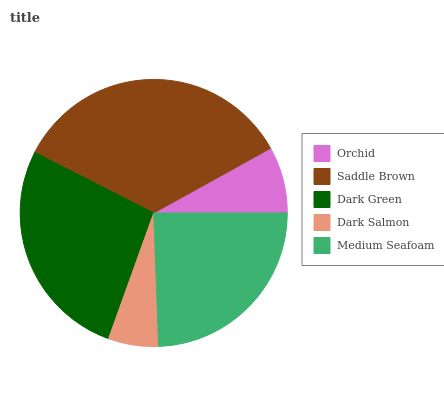Is Dark Salmon the minimum?
Answer yes or no. Yes. Is Saddle Brown the maximum?
Answer yes or no. Yes. Is Dark Green the minimum?
Answer yes or no. No. Is Dark Green the maximum?
Answer yes or no. No. Is Saddle Brown greater than Dark Green?
Answer yes or no. Yes. Is Dark Green less than Saddle Brown?
Answer yes or no. Yes. Is Dark Green greater than Saddle Brown?
Answer yes or no. No. Is Saddle Brown less than Dark Green?
Answer yes or no. No. Is Medium Seafoam the high median?
Answer yes or no. Yes. Is Medium Seafoam the low median?
Answer yes or no. Yes. Is Orchid the high median?
Answer yes or no. No. Is Dark Salmon the low median?
Answer yes or no. No. 